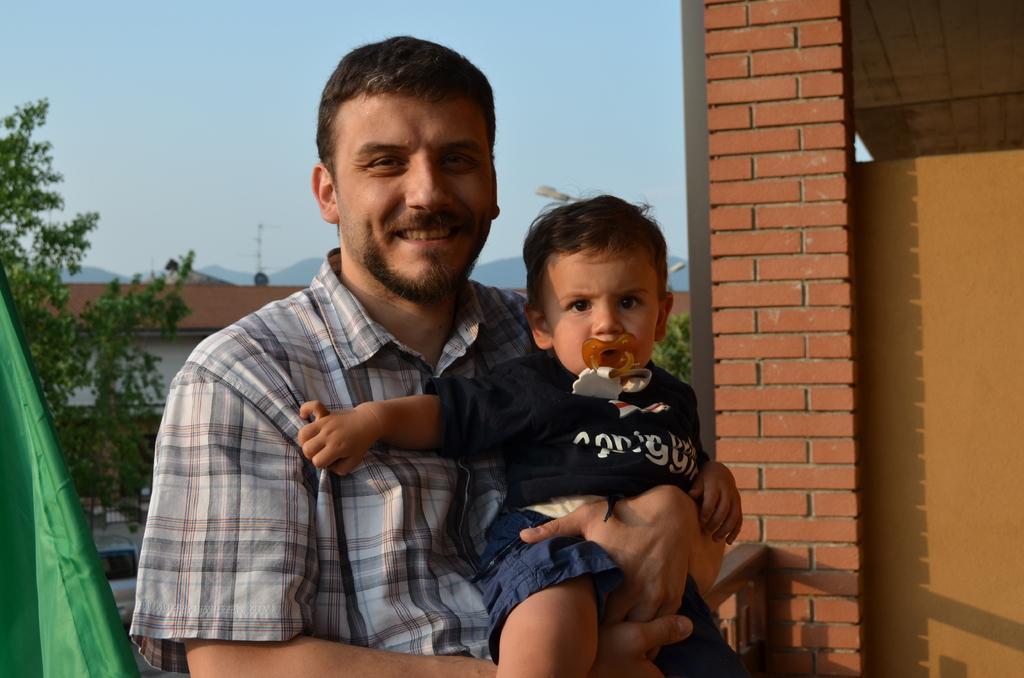Can you describe this image briefly? This man is smiling and holding a baby. Background there are trees and buildings. This is brick wall. 